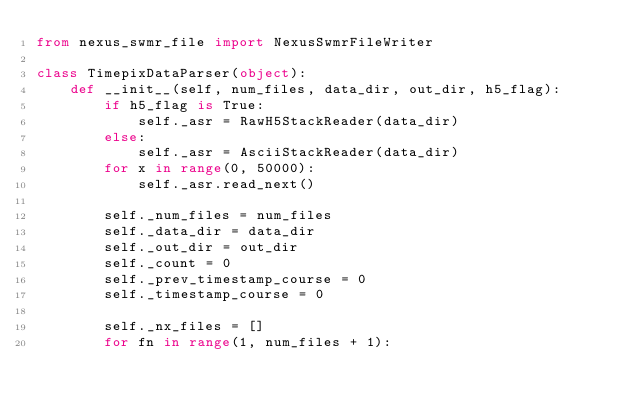<code> <loc_0><loc_0><loc_500><loc_500><_Python_>from nexus_swmr_file import NexusSwmrFileWriter

class TimepixDataParser(object):
    def __init__(self, num_files, data_dir, out_dir, h5_flag):
        if h5_flag is True:
            self._asr = RawH5StackReader(data_dir)
        else:
            self._asr = AsciiStackReader(data_dir)
        for x in range(0, 50000):
            self._asr.read_next()

        self._num_files = num_files
        self._data_dir = data_dir
        self._out_dir = out_dir
        self._count = 0
        self._prev_timestamp_course = 0
        self._timestamp_course = 0

        self._nx_files = []
        for fn in range(1, num_files + 1):</code> 